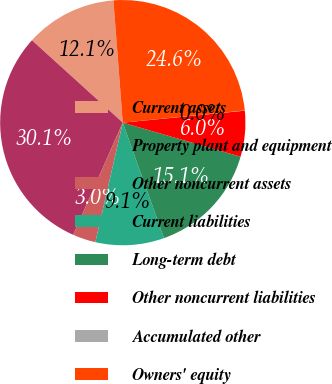Convert chart to OTSL. <chart><loc_0><loc_0><loc_500><loc_500><pie_chart><fcel>Current assets<fcel>Property plant and equipment<fcel>Other noncurrent assets<fcel>Current liabilities<fcel>Long-term debt<fcel>Other noncurrent liabilities<fcel>Accumulated other<fcel>Owners' equity<nl><fcel>12.06%<fcel>30.1%<fcel>3.03%<fcel>9.05%<fcel>15.06%<fcel>6.04%<fcel>0.03%<fcel>24.63%<nl></chart> 